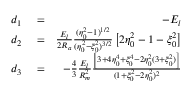<formula> <loc_0><loc_0><loc_500><loc_500>\begin{array} { r l r } { d _ { 1 } } & = } & { - E _ { l } } \\ { d _ { 2 } } & = } & { \frac { E _ { l } } { 2 R _ { a } } \frac { ( \eta _ { 0 } ^ { 2 } - 1 ) ^ { 1 / 2 } } { ( \eta _ { 0 } ^ { 2 } - \xi _ { 0 } ^ { 2 } ) ^ { 3 / 2 } } \left [ 2 \eta _ { 0 } ^ { 2 } - 1 - \xi _ { 0 } ^ { 2 } \right ] } \\ { d _ { 3 } } & = } & { - \frac { 4 } { 3 } \frac { E _ { l } } { R _ { m } ^ { 2 } } \frac { \left [ 3 + 4 \eta _ { 0 } ^ { 4 } + \xi _ { 0 } ^ { 4 } - 2 \eta _ { 0 } ^ { 2 } ( 3 + \xi _ { 0 } ^ { 2 } ) \right ] } { ( 1 + \xi _ { 0 } ^ { 2 } - 2 \eta _ { 0 } ^ { 2 } ) ^ { 2 } } } \end{array}</formula> 